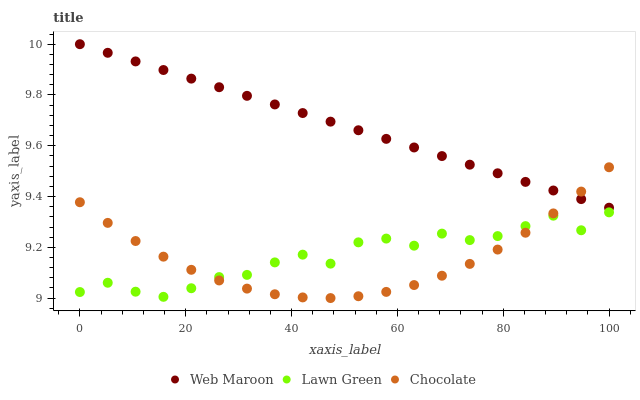Does Chocolate have the minimum area under the curve?
Answer yes or no. Yes. Does Web Maroon have the maximum area under the curve?
Answer yes or no. Yes. Does Web Maroon have the minimum area under the curve?
Answer yes or no. No. Does Chocolate have the maximum area under the curve?
Answer yes or no. No. Is Web Maroon the smoothest?
Answer yes or no. Yes. Is Lawn Green the roughest?
Answer yes or no. Yes. Is Chocolate the smoothest?
Answer yes or no. No. Is Chocolate the roughest?
Answer yes or no. No. Does Chocolate have the lowest value?
Answer yes or no. Yes. Does Web Maroon have the lowest value?
Answer yes or no. No. Does Web Maroon have the highest value?
Answer yes or no. Yes. Does Chocolate have the highest value?
Answer yes or no. No. Is Lawn Green less than Web Maroon?
Answer yes or no. Yes. Is Web Maroon greater than Lawn Green?
Answer yes or no. Yes. Does Lawn Green intersect Chocolate?
Answer yes or no. Yes. Is Lawn Green less than Chocolate?
Answer yes or no. No. Is Lawn Green greater than Chocolate?
Answer yes or no. No. Does Lawn Green intersect Web Maroon?
Answer yes or no. No. 